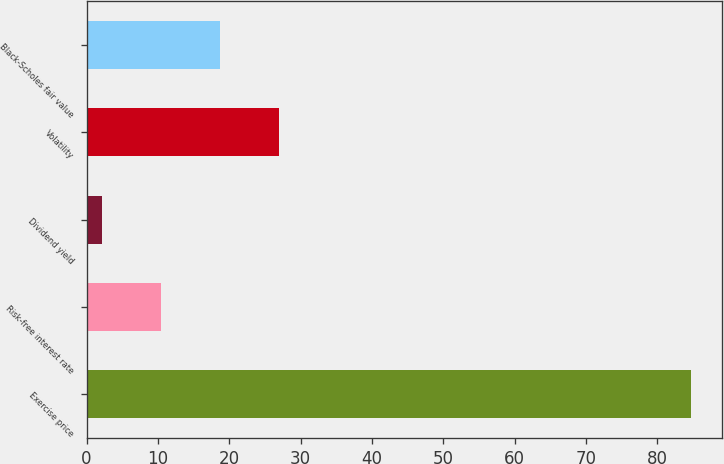<chart> <loc_0><loc_0><loc_500><loc_500><bar_chart><fcel>Exercise price<fcel>Risk-free interest rate<fcel>Dividend yield<fcel>Volatility<fcel>Black-Scholes fair value<nl><fcel>84.79<fcel>10.37<fcel>2.1<fcel>26.91<fcel>18.64<nl></chart> 